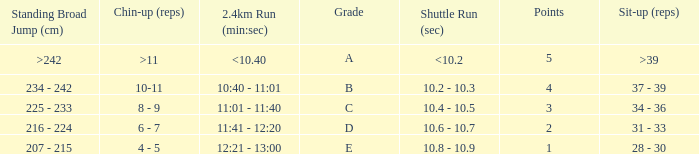Write the full table. {'header': ['Standing Broad Jump (cm)', 'Chin-up (reps)', '2.4km Run (min:sec)', 'Grade', 'Shuttle Run (sec)', 'Points', 'Sit-up (reps)'], 'rows': [['>242', '>11', '<10.40', 'A', '<10.2', '5', '>39'], ['234 - 242', '10-11', '10:40 - 11:01', 'B', '10.2 - 10.3', '4', '37 - 39'], ['225 - 233', '8 - 9', '11:01 - 11:40', 'C', '10.4 - 10.5', '3', '34 - 36'], ['216 - 224', '6 - 7', '11:41 - 12:20', 'D', '10.6 - 10.7', '2', '31 - 33'], ['207 - 215', '4 - 5', '12:21 - 13:00', 'E', '10.8 - 10.9', '1', '28 - 30']]} Tell me the shuttle run with grade c 10.4 - 10.5. 